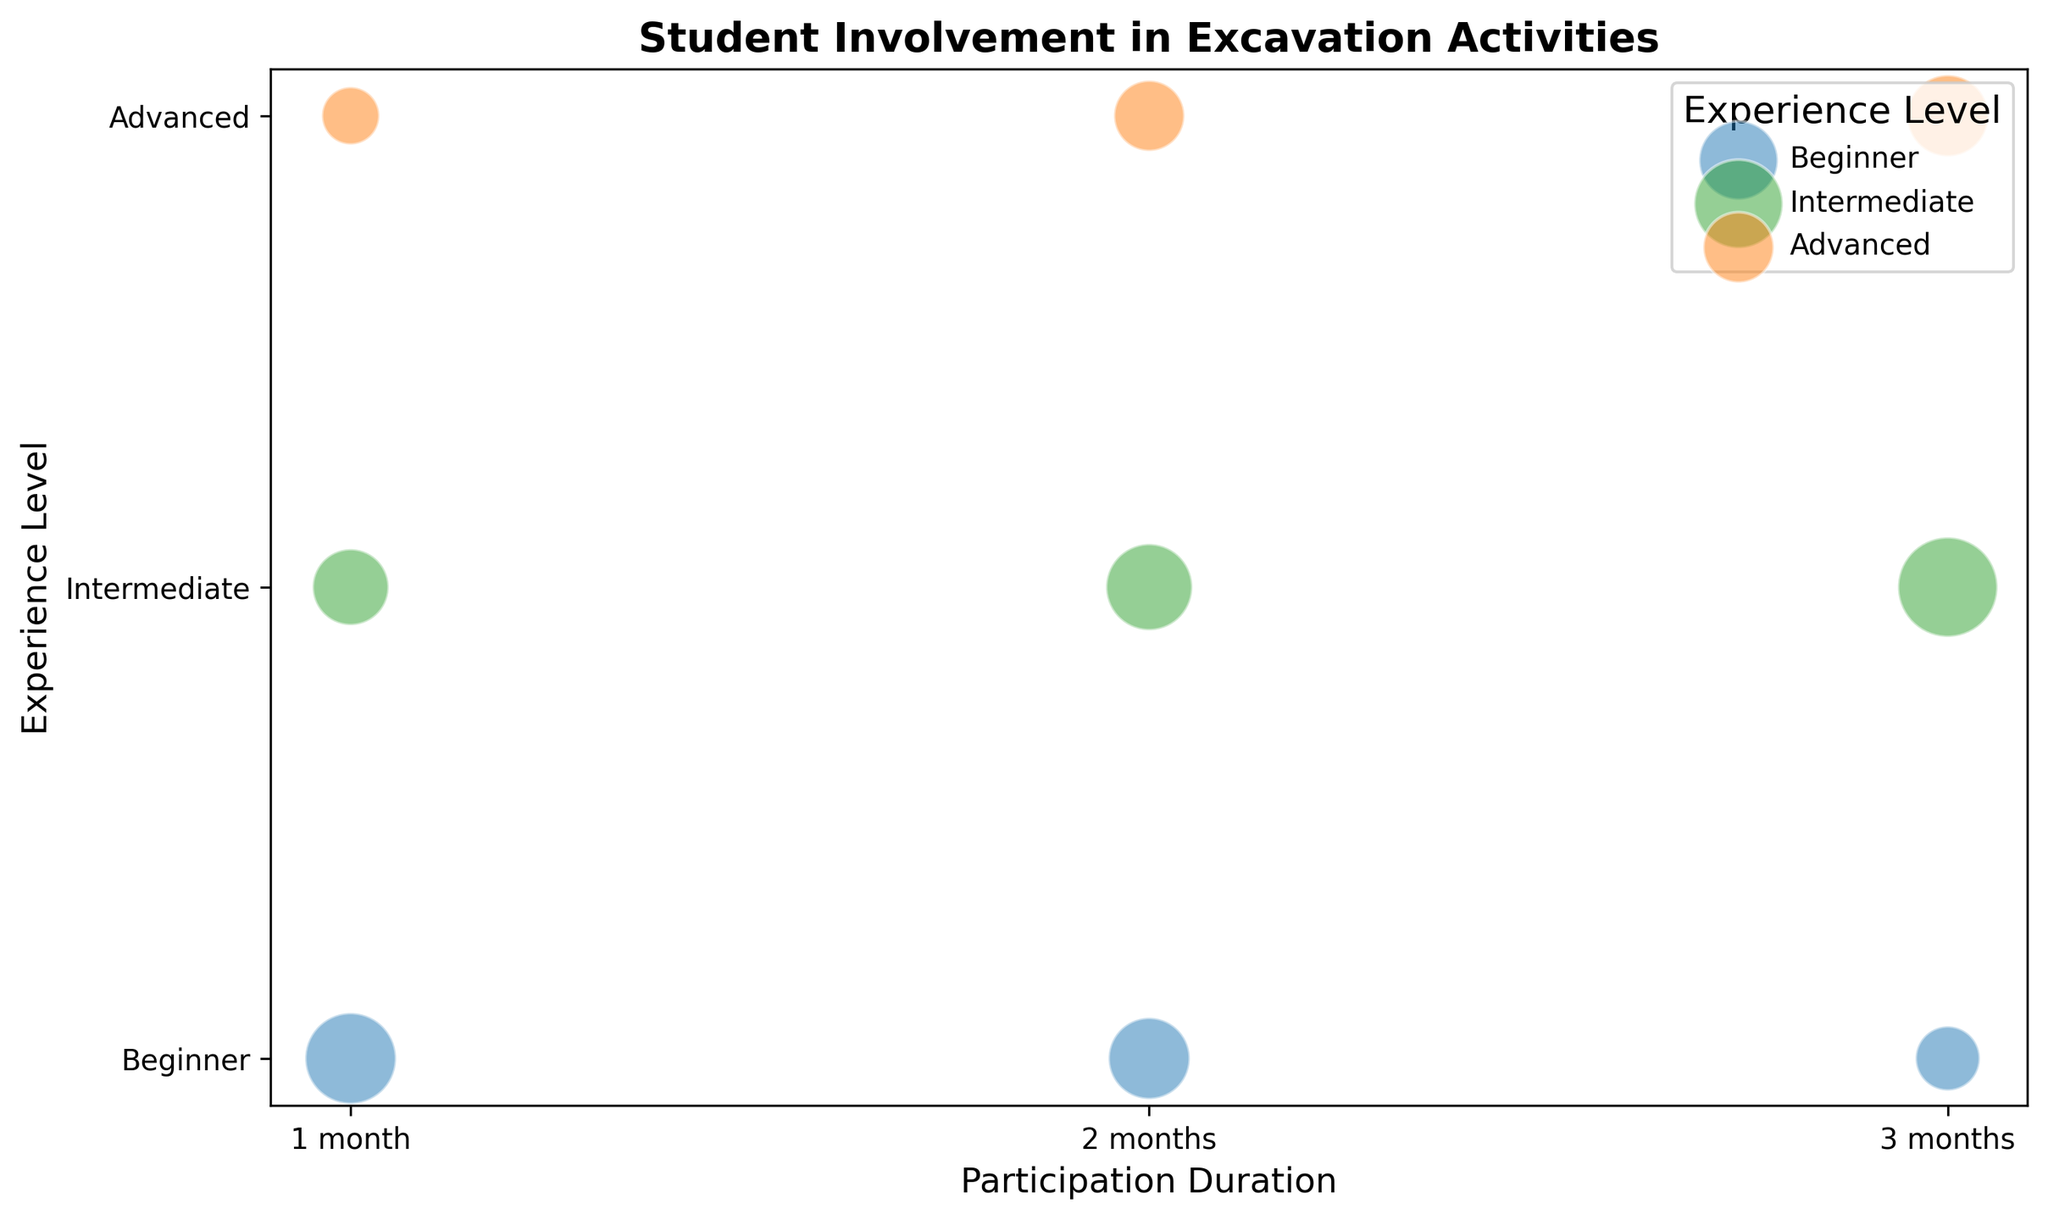Which experience level has the most students with 3 months of participation? Look at the bubble plot and compare the sizes of the bubbles at 3 months for each experience level. The Intermediate level has the largest bubble, indicating the most students.
Answer: Intermediate How many more students are there in the Advanced level with 3 months of participation compared to 1 month? Find the bubbles for the Advanced level at 1-month and 3-months durations. The 3-months bubble represents 8 students, and the 1-months bubble represents 4 students. Subtracting the two gives 8 - 4 = 4.
Answer: 4 Which participation duration has the most number of students across all experience levels? Compare the combined bubble sizes for 1 month, 2 months, and 3 months. Count the number of students at each duration: 1 month (10 + 7 + 4 = 21), 2 months (8 + 9 + 6 = 23), and 3 months (5 + 12 + 8 = 25). 3 months has the largest total.
Answer: 3 months Do the Beginner and Advanced levels have the same number of students with 2 months of participation? Compare the size of the bubbles for Beginner and Advanced at 2 months. Beginners have 8 students and Advanced levels have 6 students. These are not equal.
Answer: No Which experience level has the smallest participation in 1 month? Compare the bubble sizes for 1 month across all experience levels. The Advanced bubble is the smallest, indicating the fewest students.
Answer: Advanced How many total students participated for 2 months across all experience levels? Sum the number of students for each experience level at 2 months: Beginner (8), Intermediate (9), Advanced (6). 8 + 9 + 6 = 23 students.
Answer: 23 Which experience level shows the most consistent number of participants across all durations? Look at the pattern of the bubble sizes for each experience level across different durations. The Beginners have decreasing bubbles, Intermediate has increasing bubbles, while Advanced shows increasing participants consistently.
Answer: Advanced 